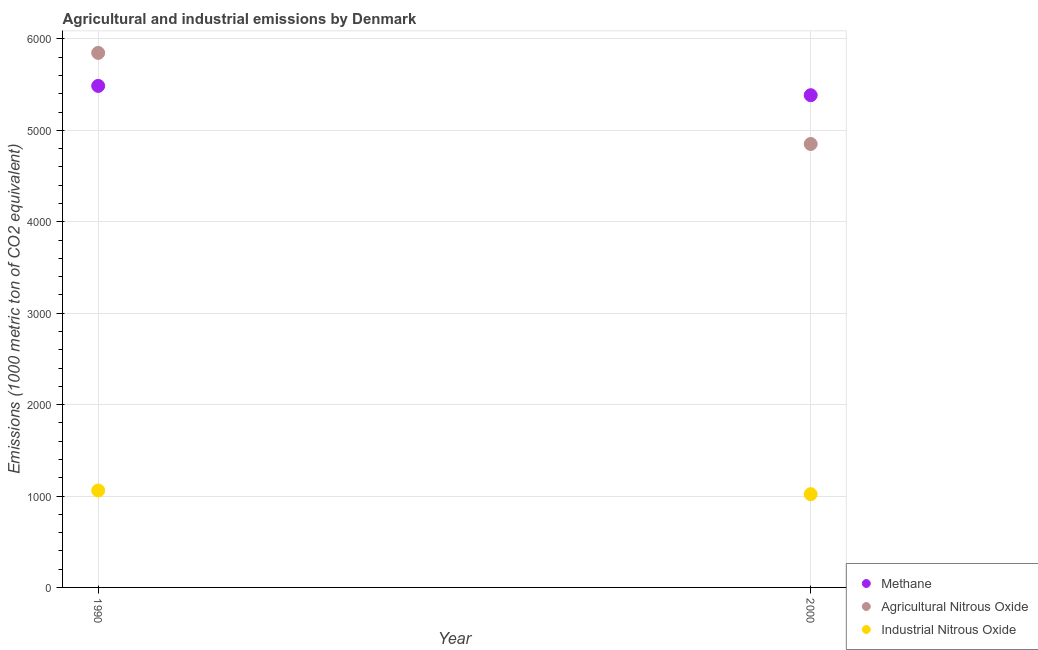How many different coloured dotlines are there?
Ensure brevity in your answer.  3. Is the number of dotlines equal to the number of legend labels?
Your answer should be compact. Yes. What is the amount of methane emissions in 2000?
Keep it short and to the point. 5384.6. Across all years, what is the maximum amount of methane emissions?
Your answer should be compact. 5486.2. Across all years, what is the minimum amount of agricultural nitrous oxide emissions?
Offer a terse response. 4850.8. In which year was the amount of methane emissions minimum?
Offer a terse response. 2000. What is the total amount of agricultural nitrous oxide emissions in the graph?
Offer a very short reply. 1.07e+04. What is the difference between the amount of agricultural nitrous oxide emissions in 1990 and that in 2000?
Keep it short and to the point. 996.6. What is the difference between the amount of industrial nitrous oxide emissions in 1990 and the amount of methane emissions in 2000?
Give a very brief answer. -4324.4. What is the average amount of agricultural nitrous oxide emissions per year?
Your answer should be compact. 5349.1. In the year 1990, what is the difference between the amount of agricultural nitrous oxide emissions and amount of methane emissions?
Your answer should be compact. 361.2. What is the ratio of the amount of methane emissions in 1990 to that in 2000?
Give a very brief answer. 1.02. In how many years, is the amount of agricultural nitrous oxide emissions greater than the average amount of agricultural nitrous oxide emissions taken over all years?
Ensure brevity in your answer.  1. Does the amount of industrial nitrous oxide emissions monotonically increase over the years?
Your response must be concise. No. Is the amount of methane emissions strictly less than the amount of industrial nitrous oxide emissions over the years?
Give a very brief answer. No. How many dotlines are there?
Your response must be concise. 3. How many years are there in the graph?
Provide a succinct answer. 2. Where does the legend appear in the graph?
Offer a terse response. Bottom right. What is the title of the graph?
Your answer should be compact. Agricultural and industrial emissions by Denmark. Does "Ages 0-14" appear as one of the legend labels in the graph?
Your answer should be very brief. No. What is the label or title of the X-axis?
Ensure brevity in your answer.  Year. What is the label or title of the Y-axis?
Offer a terse response. Emissions (1000 metric ton of CO2 equivalent). What is the Emissions (1000 metric ton of CO2 equivalent) in Methane in 1990?
Your answer should be very brief. 5486.2. What is the Emissions (1000 metric ton of CO2 equivalent) in Agricultural Nitrous Oxide in 1990?
Ensure brevity in your answer.  5847.4. What is the Emissions (1000 metric ton of CO2 equivalent) of Industrial Nitrous Oxide in 1990?
Your answer should be compact. 1060.2. What is the Emissions (1000 metric ton of CO2 equivalent) in Methane in 2000?
Keep it short and to the point. 5384.6. What is the Emissions (1000 metric ton of CO2 equivalent) in Agricultural Nitrous Oxide in 2000?
Your answer should be very brief. 4850.8. What is the Emissions (1000 metric ton of CO2 equivalent) of Industrial Nitrous Oxide in 2000?
Provide a succinct answer. 1020.1. Across all years, what is the maximum Emissions (1000 metric ton of CO2 equivalent) of Methane?
Keep it short and to the point. 5486.2. Across all years, what is the maximum Emissions (1000 metric ton of CO2 equivalent) of Agricultural Nitrous Oxide?
Your answer should be compact. 5847.4. Across all years, what is the maximum Emissions (1000 metric ton of CO2 equivalent) of Industrial Nitrous Oxide?
Offer a very short reply. 1060.2. Across all years, what is the minimum Emissions (1000 metric ton of CO2 equivalent) of Methane?
Your answer should be compact. 5384.6. Across all years, what is the minimum Emissions (1000 metric ton of CO2 equivalent) of Agricultural Nitrous Oxide?
Your response must be concise. 4850.8. Across all years, what is the minimum Emissions (1000 metric ton of CO2 equivalent) of Industrial Nitrous Oxide?
Your response must be concise. 1020.1. What is the total Emissions (1000 metric ton of CO2 equivalent) of Methane in the graph?
Your answer should be compact. 1.09e+04. What is the total Emissions (1000 metric ton of CO2 equivalent) in Agricultural Nitrous Oxide in the graph?
Your response must be concise. 1.07e+04. What is the total Emissions (1000 metric ton of CO2 equivalent) of Industrial Nitrous Oxide in the graph?
Offer a terse response. 2080.3. What is the difference between the Emissions (1000 metric ton of CO2 equivalent) of Methane in 1990 and that in 2000?
Your response must be concise. 101.6. What is the difference between the Emissions (1000 metric ton of CO2 equivalent) in Agricultural Nitrous Oxide in 1990 and that in 2000?
Provide a succinct answer. 996.6. What is the difference between the Emissions (1000 metric ton of CO2 equivalent) of Industrial Nitrous Oxide in 1990 and that in 2000?
Keep it short and to the point. 40.1. What is the difference between the Emissions (1000 metric ton of CO2 equivalent) of Methane in 1990 and the Emissions (1000 metric ton of CO2 equivalent) of Agricultural Nitrous Oxide in 2000?
Your answer should be compact. 635.4. What is the difference between the Emissions (1000 metric ton of CO2 equivalent) in Methane in 1990 and the Emissions (1000 metric ton of CO2 equivalent) in Industrial Nitrous Oxide in 2000?
Offer a terse response. 4466.1. What is the difference between the Emissions (1000 metric ton of CO2 equivalent) in Agricultural Nitrous Oxide in 1990 and the Emissions (1000 metric ton of CO2 equivalent) in Industrial Nitrous Oxide in 2000?
Ensure brevity in your answer.  4827.3. What is the average Emissions (1000 metric ton of CO2 equivalent) in Methane per year?
Keep it short and to the point. 5435.4. What is the average Emissions (1000 metric ton of CO2 equivalent) of Agricultural Nitrous Oxide per year?
Provide a short and direct response. 5349.1. What is the average Emissions (1000 metric ton of CO2 equivalent) in Industrial Nitrous Oxide per year?
Give a very brief answer. 1040.15. In the year 1990, what is the difference between the Emissions (1000 metric ton of CO2 equivalent) of Methane and Emissions (1000 metric ton of CO2 equivalent) of Agricultural Nitrous Oxide?
Your response must be concise. -361.2. In the year 1990, what is the difference between the Emissions (1000 metric ton of CO2 equivalent) of Methane and Emissions (1000 metric ton of CO2 equivalent) of Industrial Nitrous Oxide?
Offer a terse response. 4426. In the year 1990, what is the difference between the Emissions (1000 metric ton of CO2 equivalent) in Agricultural Nitrous Oxide and Emissions (1000 metric ton of CO2 equivalent) in Industrial Nitrous Oxide?
Offer a terse response. 4787.2. In the year 2000, what is the difference between the Emissions (1000 metric ton of CO2 equivalent) of Methane and Emissions (1000 metric ton of CO2 equivalent) of Agricultural Nitrous Oxide?
Offer a terse response. 533.8. In the year 2000, what is the difference between the Emissions (1000 metric ton of CO2 equivalent) of Methane and Emissions (1000 metric ton of CO2 equivalent) of Industrial Nitrous Oxide?
Your response must be concise. 4364.5. In the year 2000, what is the difference between the Emissions (1000 metric ton of CO2 equivalent) in Agricultural Nitrous Oxide and Emissions (1000 metric ton of CO2 equivalent) in Industrial Nitrous Oxide?
Ensure brevity in your answer.  3830.7. What is the ratio of the Emissions (1000 metric ton of CO2 equivalent) in Methane in 1990 to that in 2000?
Make the answer very short. 1.02. What is the ratio of the Emissions (1000 metric ton of CO2 equivalent) of Agricultural Nitrous Oxide in 1990 to that in 2000?
Your response must be concise. 1.21. What is the ratio of the Emissions (1000 metric ton of CO2 equivalent) of Industrial Nitrous Oxide in 1990 to that in 2000?
Ensure brevity in your answer.  1.04. What is the difference between the highest and the second highest Emissions (1000 metric ton of CO2 equivalent) of Methane?
Ensure brevity in your answer.  101.6. What is the difference between the highest and the second highest Emissions (1000 metric ton of CO2 equivalent) in Agricultural Nitrous Oxide?
Give a very brief answer. 996.6. What is the difference between the highest and the second highest Emissions (1000 metric ton of CO2 equivalent) of Industrial Nitrous Oxide?
Keep it short and to the point. 40.1. What is the difference between the highest and the lowest Emissions (1000 metric ton of CO2 equivalent) of Methane?
Give a very brief answer. 101.6. What is the difference between the highest and the lowest Emissions (1000 metric ton of CO2 equivalent) of Agricultural Nitrous Oxide?
Keep it short and to the point. 996.6. What is the difference between the highest and the lowest Emissions (1000 metric ton of CO2 equivalent) in Industrial Nitrous Oxide?
Offer a very short reply. 40.1. 